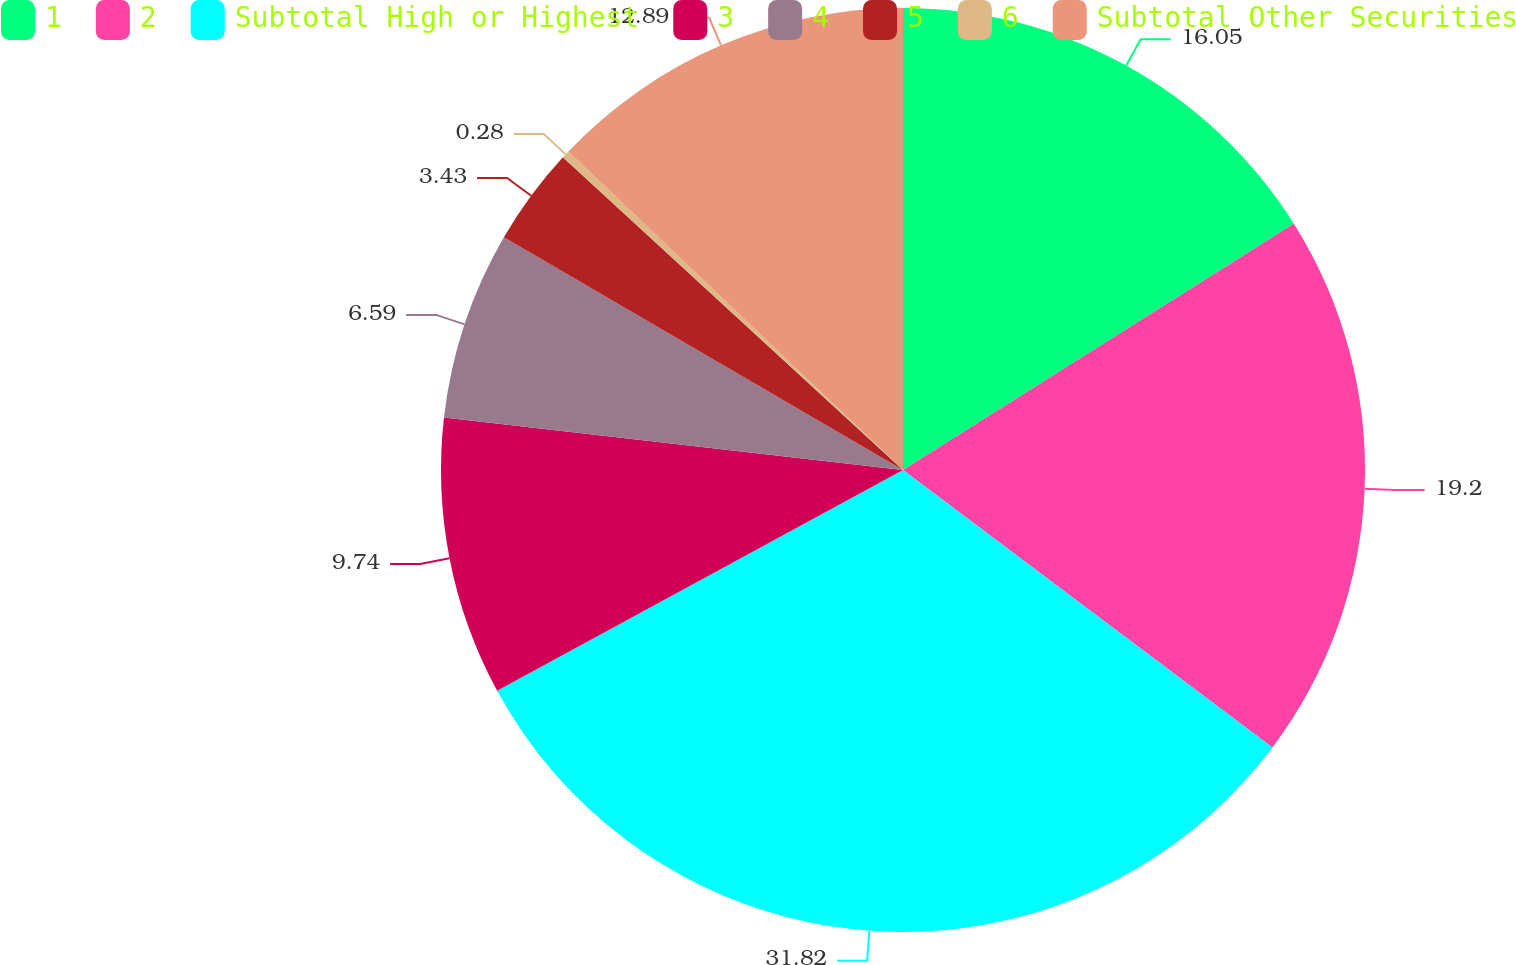Convert chart to OTSL. <chart><loc_0><loc_0><loc_500><loc_500><pie_chart><fcel>1<fcel>2<fcel>Subtotal High or Highest<fcel>3<fcel>4<fcel>5<fcel>6<fcel>Subtotal Other Securities<nl><fcel>16.05%<fcel>19.2%<fcel>31.82%<fcel>9.74%<fcel>6.59%<fcel>3.43%<fcel>0.28%<fcel>12.89%<nl></chart> 